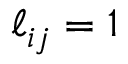Convert formula to latex. <formula><loc_0><loc_0><loc_500><loc_500>\ell _ { i j } = 1</formula> 